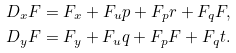<formula> <loc_0><loc_0><loc_500><loc_500>D _ { x } F & = F _ { x } + F _ { u } p + F _ { p } r + F _ { q } F , \\ D _ { y } F & = F _ { y } + F _ { u } q + F _ { p } F + F _ { q } t .</formula> 